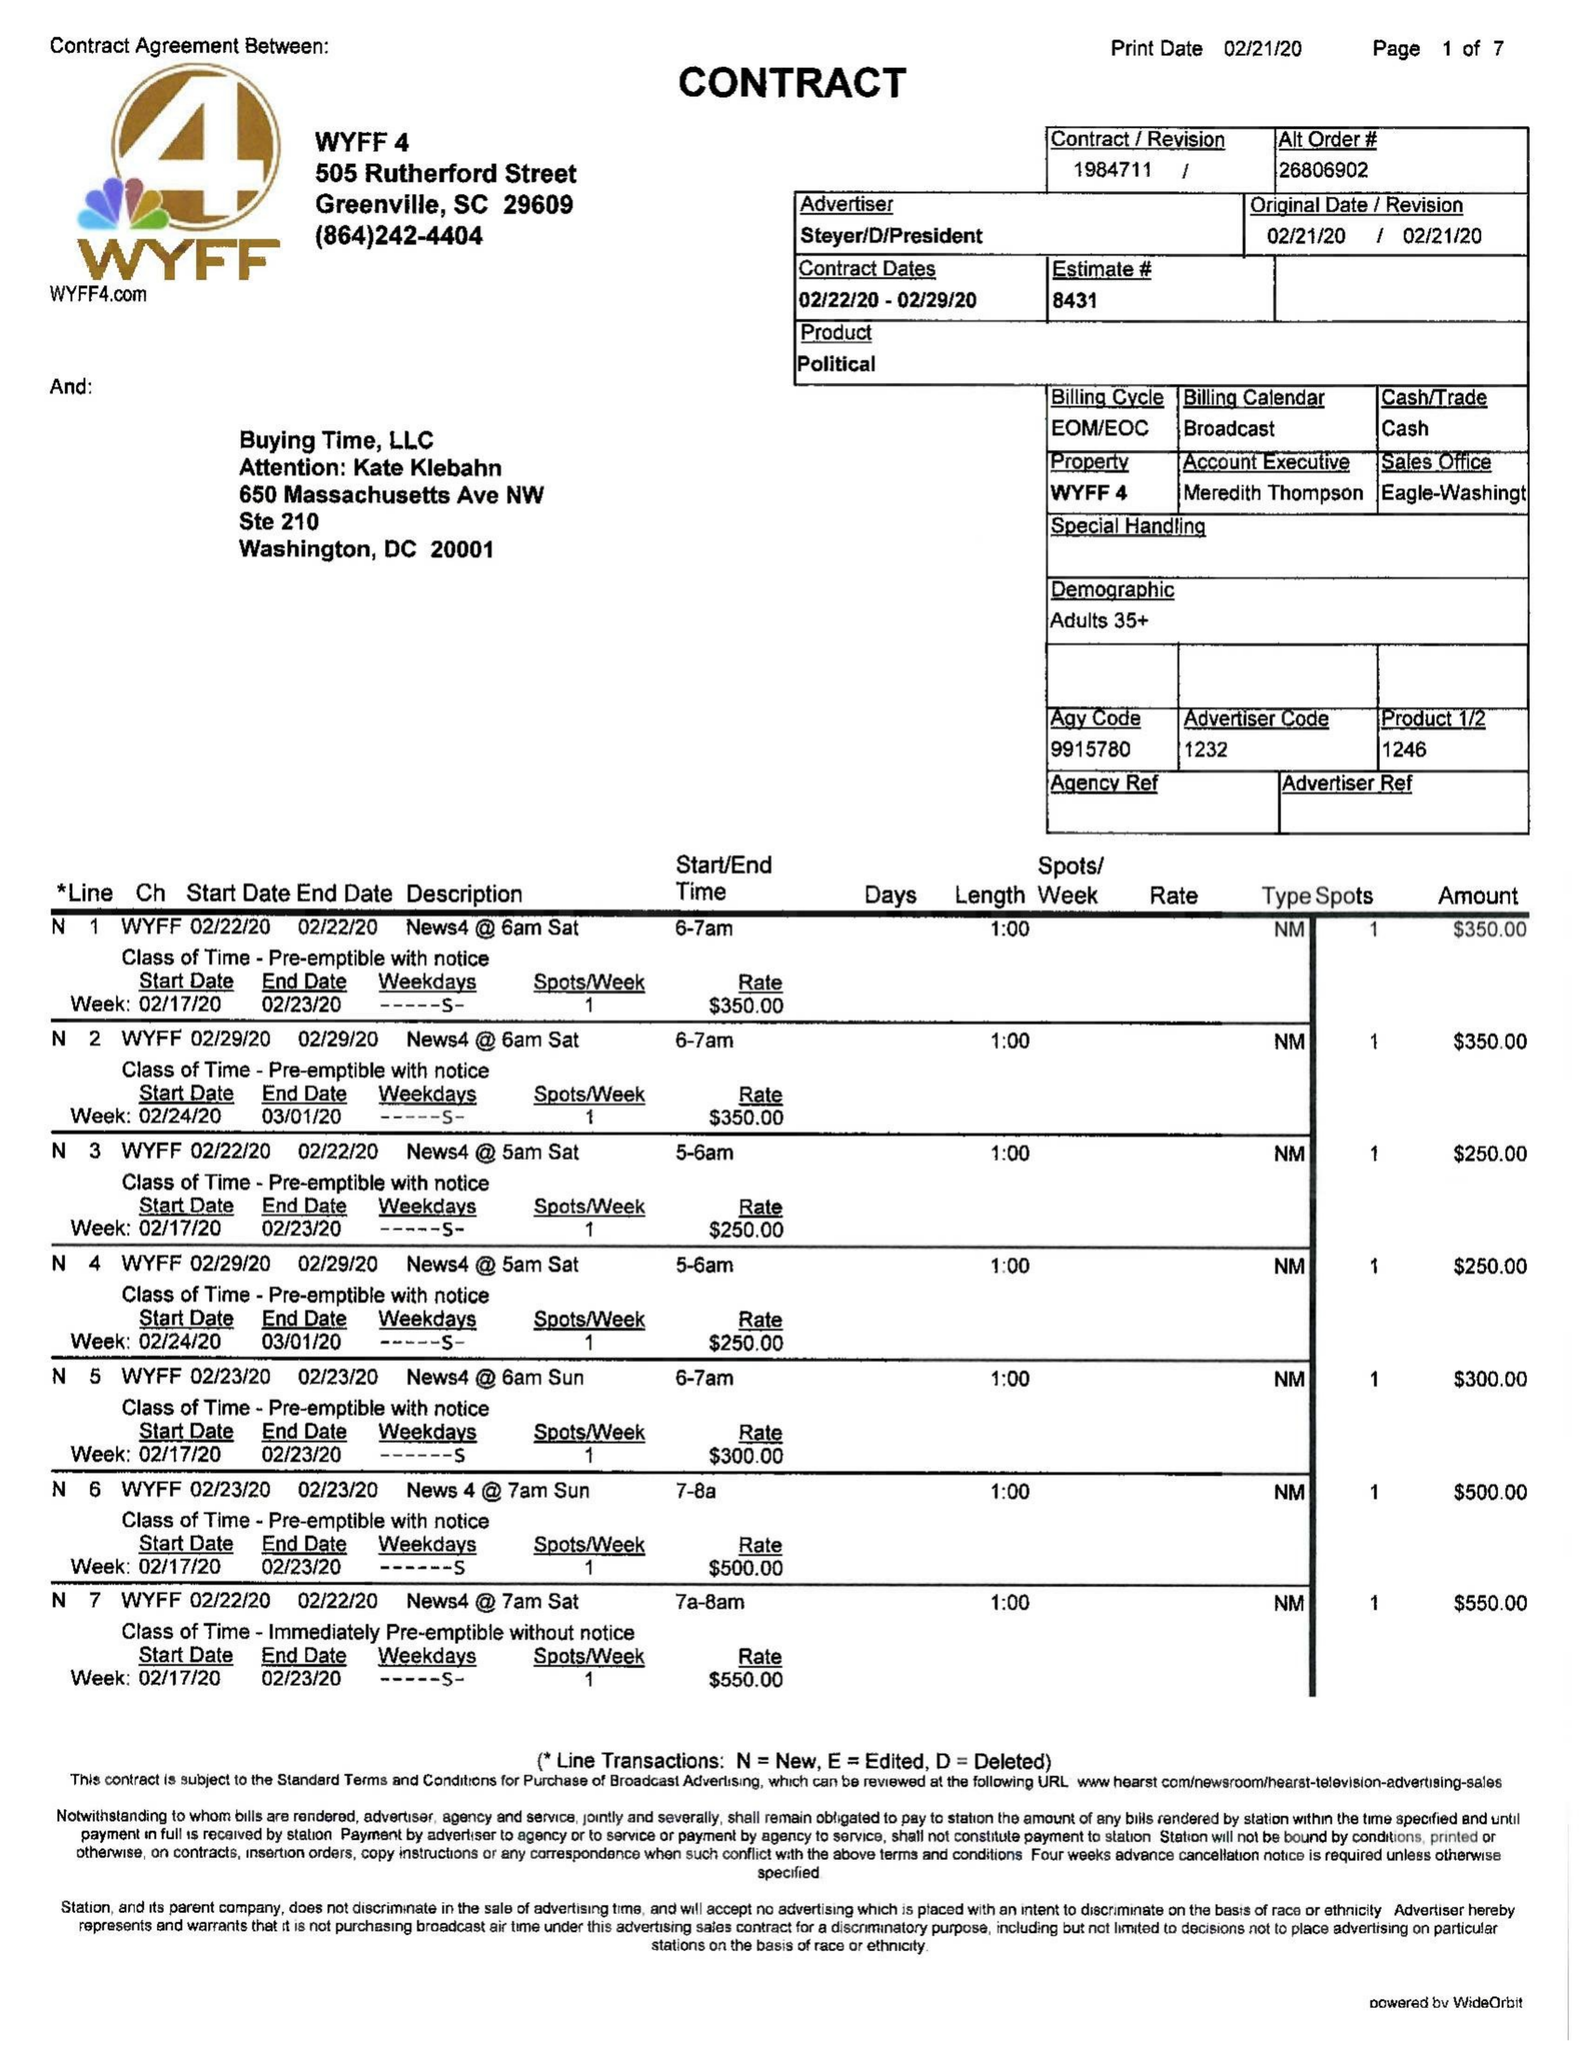What is the value for the flight_from?
Answer the question using a single word or phrase. 02/22/20 